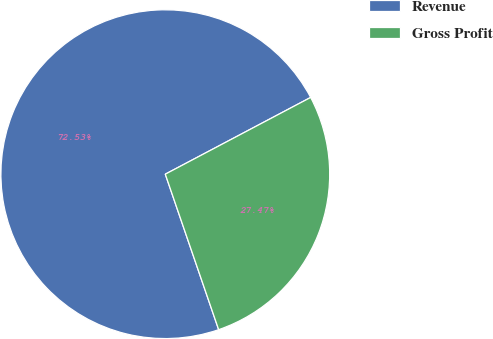Convert chart to OTSL. <chart><loc_0><loc_0><loc_500><loc_500><pie_chart><fcel>Revenue<fcel>Gross Profit<nl><fcel>72.53%<fcel>27.47%<nl></chart> 